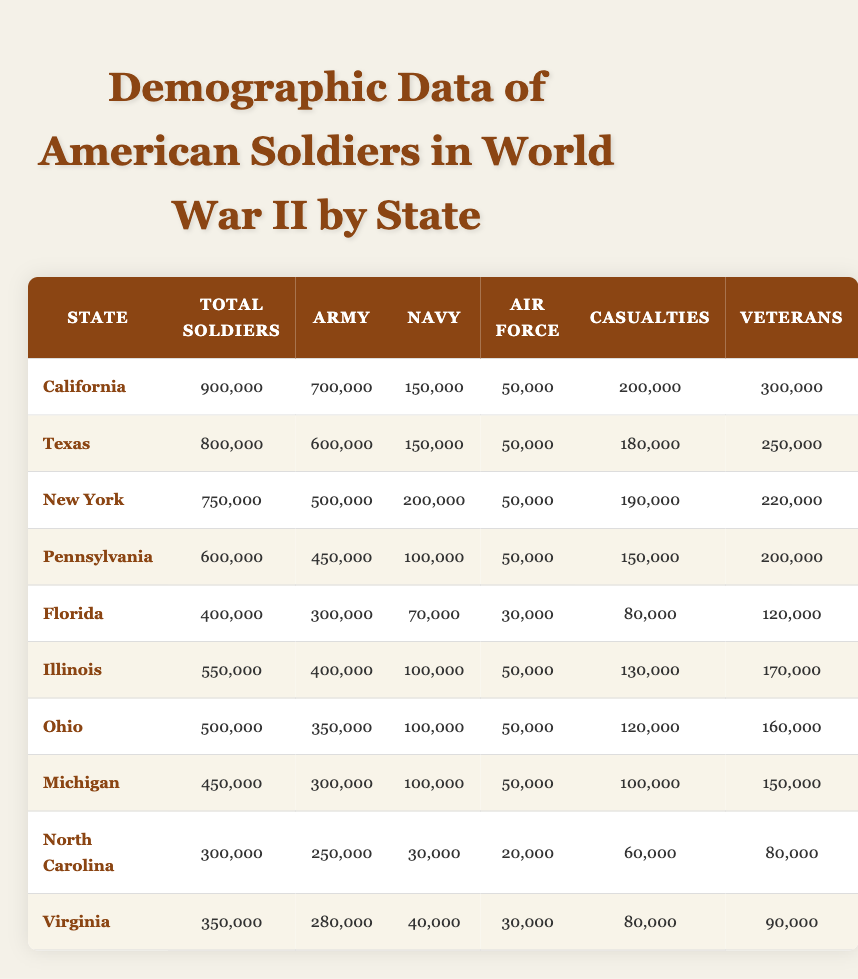What is the total number of soldiers from California? Looking at the row for California in the table, the column labeled "Total Soldiers" shows 900,000.
Answer: 900,000 Which state had the highest number of casualties? By comparing the "Casualties" figures, California has 200,000, Texas has 180,000, New York has 190,000, and so on. California has the highest with 200,000 casualties.
Answer: California What is the total number of soldiers from the states with more than 500,000 total soldiers? The states with more than 500,000 soldiers are California (900,000), Texas (800,000), and New York (750,000). Adding these gives 900,000 + 800,000 + 750,000 = 2,450,000 in total.
Answer: 2,450,000 Did Virginia have more Army soldiers than Florida? Virginia has 280,000 Army soldiers, while Florida has 300,000 Army soldiers. Therefore, Virginia did not have more Army soldiers than Florida.
Answer: No What is the average number of Navy soldiers from the states listed? The Navy soldier counts are: California (150,000), Texas (150,000), New York (200,000), Pennsylvania (100,000), Florida (70,000), Illinois (100,000), Ohio (100,000), Michigan (100,000), North Carolina (30,000), Virginia (40,000). Summing these gives 1,040,000. There are 10 states, so the average is 1,040,000 / 10 = 104,000.
Answer: 104,000 How many Veterans did the state of Illinois have compared to the state of Ohio? Illinois has 170,000 Veterans while Ohio has 160,000. Therefore, Illinois had more Veterans than Ohio.
Answer: Yes What percentage of total soldiers from New York were Navy personnel? For New York, the total soldiers are 750,000 and the Navy personnel are 200,000. To find the percentage, divide 200,000 by 750,000 and multiply by 100 to get (200,000 / 750,000) * 100 = 26.67%.
Answer: 26.67% What is the difference in the number of total soldiers between California and Michigan? California has 900,000 total soldiers and Michigan has 450,000 total soldiers. The difference is 900,000 - 450,000 = 450,000.
Answer: 450,000 